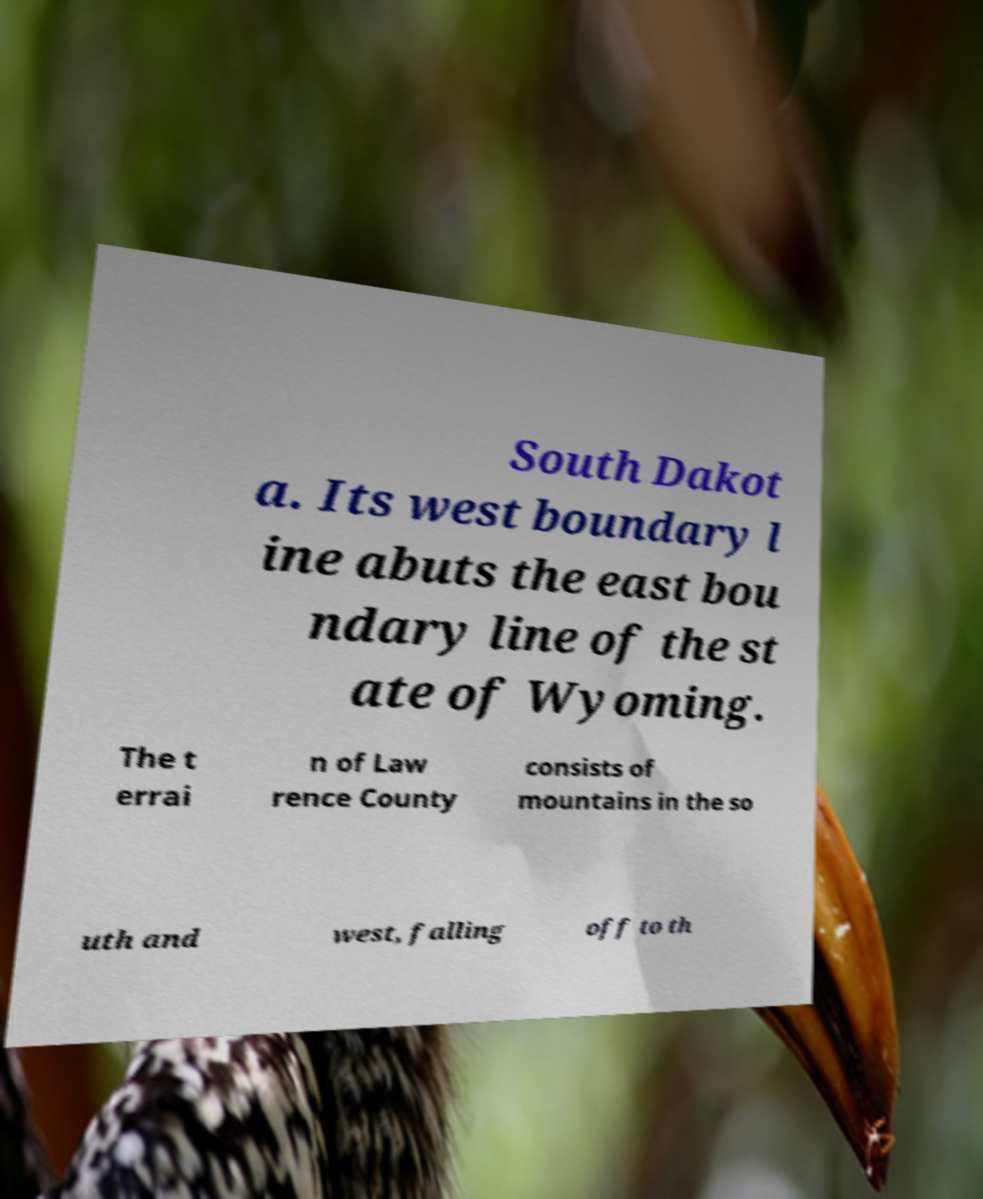Can you accurately transcribe the text from the provided image for me? South Dakot a. Its west boundary l ine abuts the east bou ndary line of the st ate of Wyoming. The t errai n of Law rence County consists of mountains in the so uth and west, falling off to th 